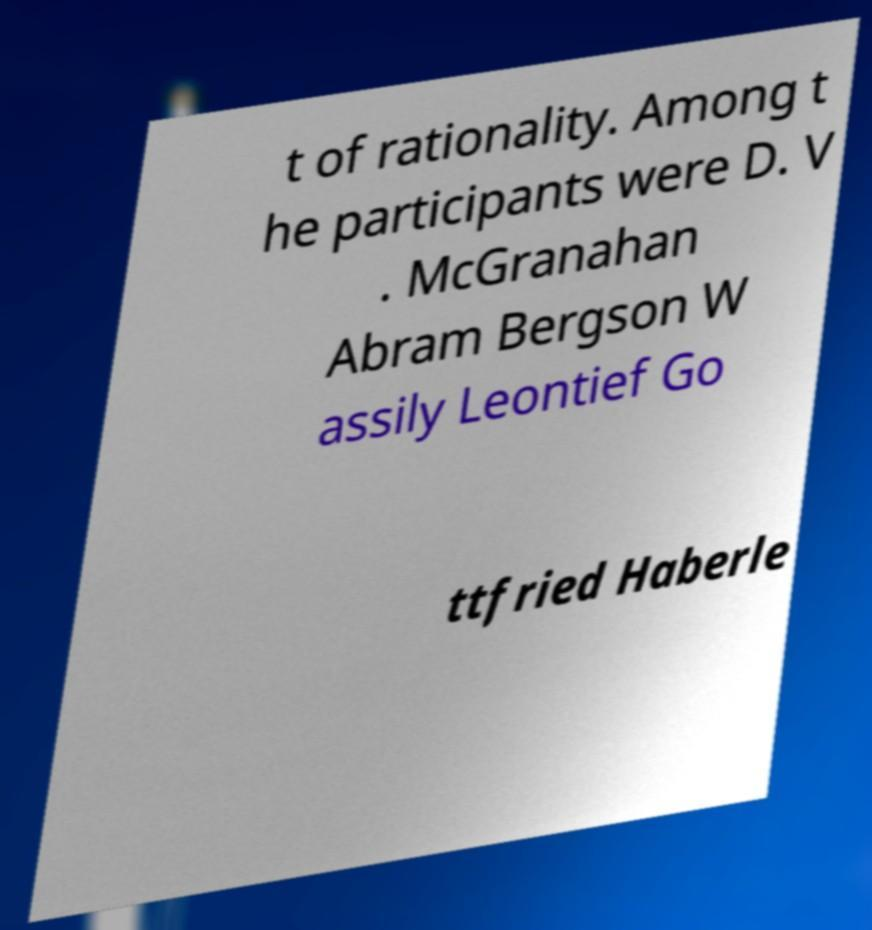What messages or text are displayed in this image? I need them in a readable, typed format. t of rationality. Among t he participants were D. V . McGranahan Abram Bergson W assily Leontief Go ttfried Haberle 